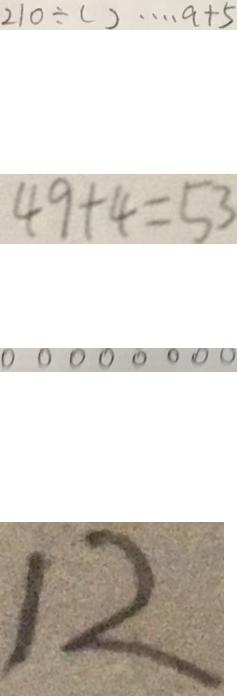Convert formula to latex. <formula><loc_0><loc_0><loc_500><loc_500>2 1 0 \div ( ) \cdots a + 5 
 4 9 + 4 = 5 3 
 0 0 0 0 0 0 0 0 
 1 2</formula> 